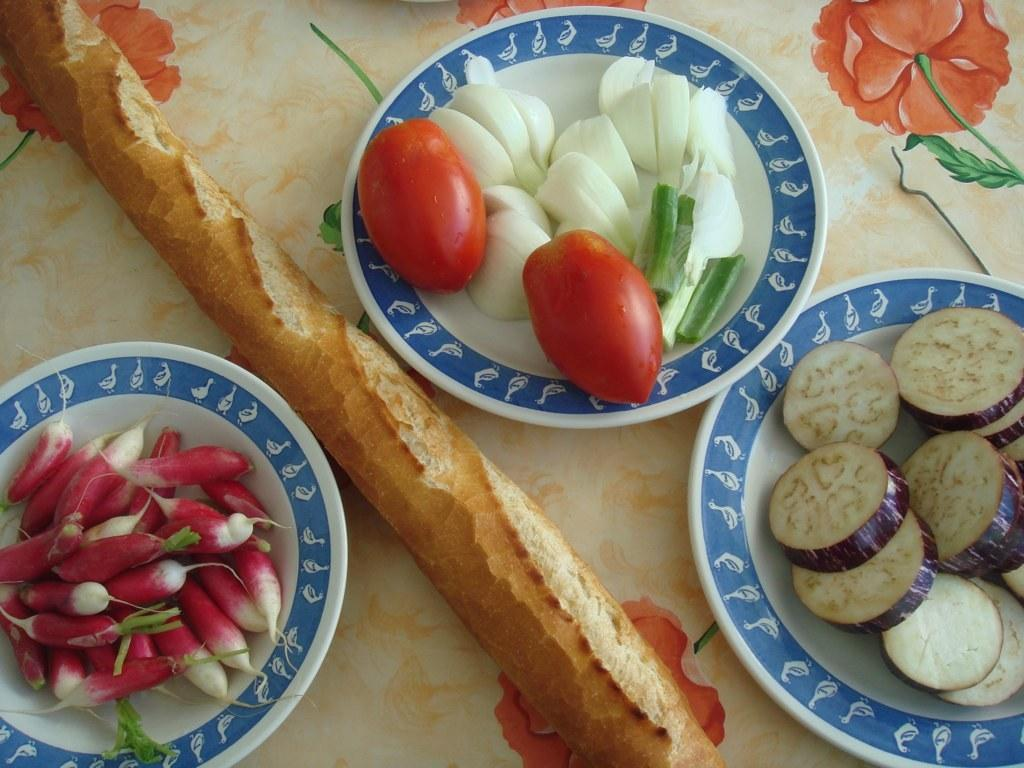What type of food can be seen in the image? There are vegetables in the image. How are the vegetables arranged in the image? The vegetables are placed in a plate. What are the colors of the plate? The plate has blue and white colors. Which specific vegetable can be identified in the plate? Tomatoes are present in the plate. What type of group is meeting in the image? There is no group meeting in the image; it features a plate of vegetables. Can you describe the lunch that is being served in the image? The image does not show a lunch being served; it only shows vegetables placed in a plate. 